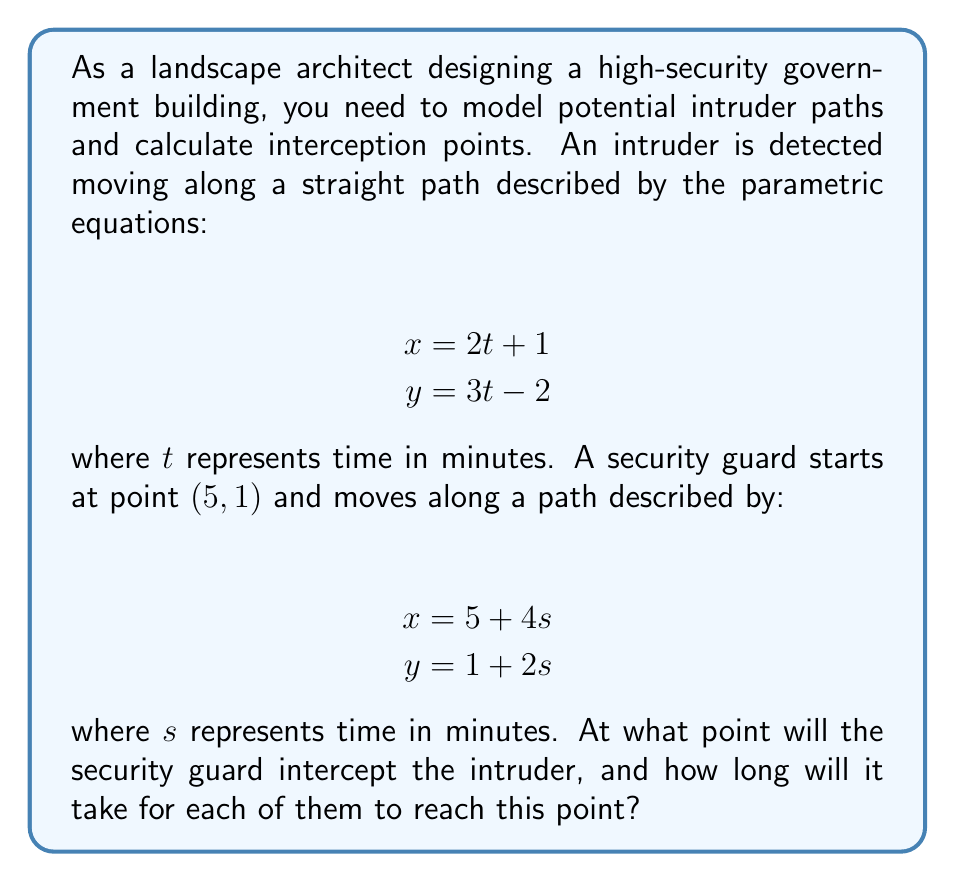Could you help me with this problem? To solve this problem, we need to find the point where the two paths intersect. This can be done by equating the x and y coordinates of both paths:

1) Equate x-coordinates:
   $$2t + 1 = 5 + 4s$$

2) Equate y-coordinates:
   $$3t - 2 = 1 + 2s$$

3) From the first equation:
   $$2t = 4 + 4s$$
   $$t = 2 + 2s$$

4) Substitute this into the second equation:
   $$3(2 + 2s) - 2 = 1 + 2s$$
   $$6 + 6s - 2 = 1 + 2s$$
   $$4 + 6s = 1 + 2s$$
   $$3 = -4s$$
   $$s = -\frac{3}{4}$$

5) Substitute this back into the equation for $t$:
   $$t = 2 + 2(-\frac{3}{4}) = 2 - \frac{3}{2} = \frac{1}{2}$$

6) Now we can find the interception point by plugging $s = -\frac{3}{4}$ into the guard's equations or $t = \frac{1}{2}$ into the intruder's equations:

   For the guard: 
   $$x = 5 + 4(-\frac{3}{4}) = 2$$
   $$y = 1 + 2(-\frac{3}{4}) = -\frac{1}{2}$$

   For the intruder:
   $$x = 2(\frac{1}{2}) + 1 = 2$$
   $$y = 3(\frac{1}{2}) - 2 = -\frac{1}{2}$$

Therefore, the interception point is $(2, -\frac{1}{2})$.

The time for the guard to reach this point is $|-\frac{3}{4}| = \frac{3}{4}$ minutes.
The time for the intruder to reach this point is $\frac{1}{2}$ minutes.
Answer: The security guard will intercept the intruder at the point $(2, -\frac{1}{2})$. It will take the guard $\frac{3}{4}$ minutes and the intruder $\frac{1}{2}$ minutes to reach this point. 